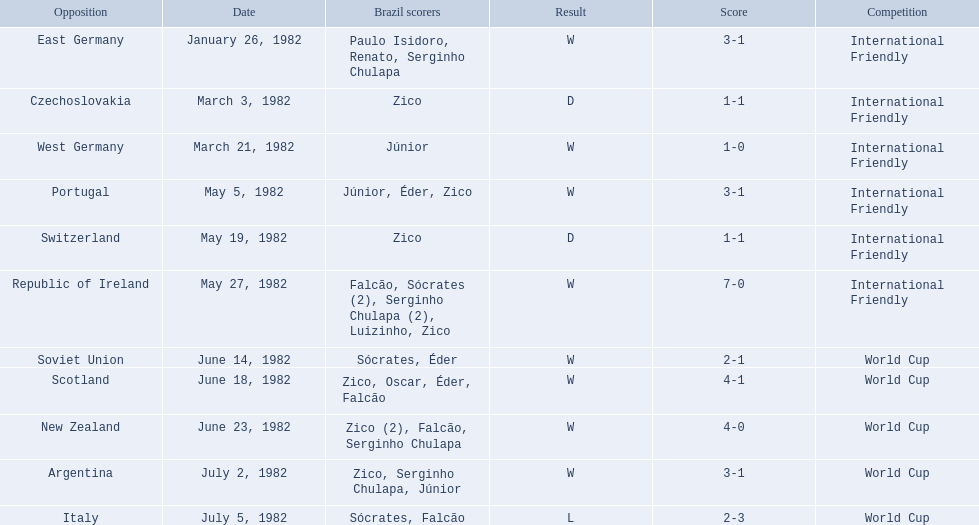Who did brazil play against Soviet Union. Who scored the most goals? Portugal. 